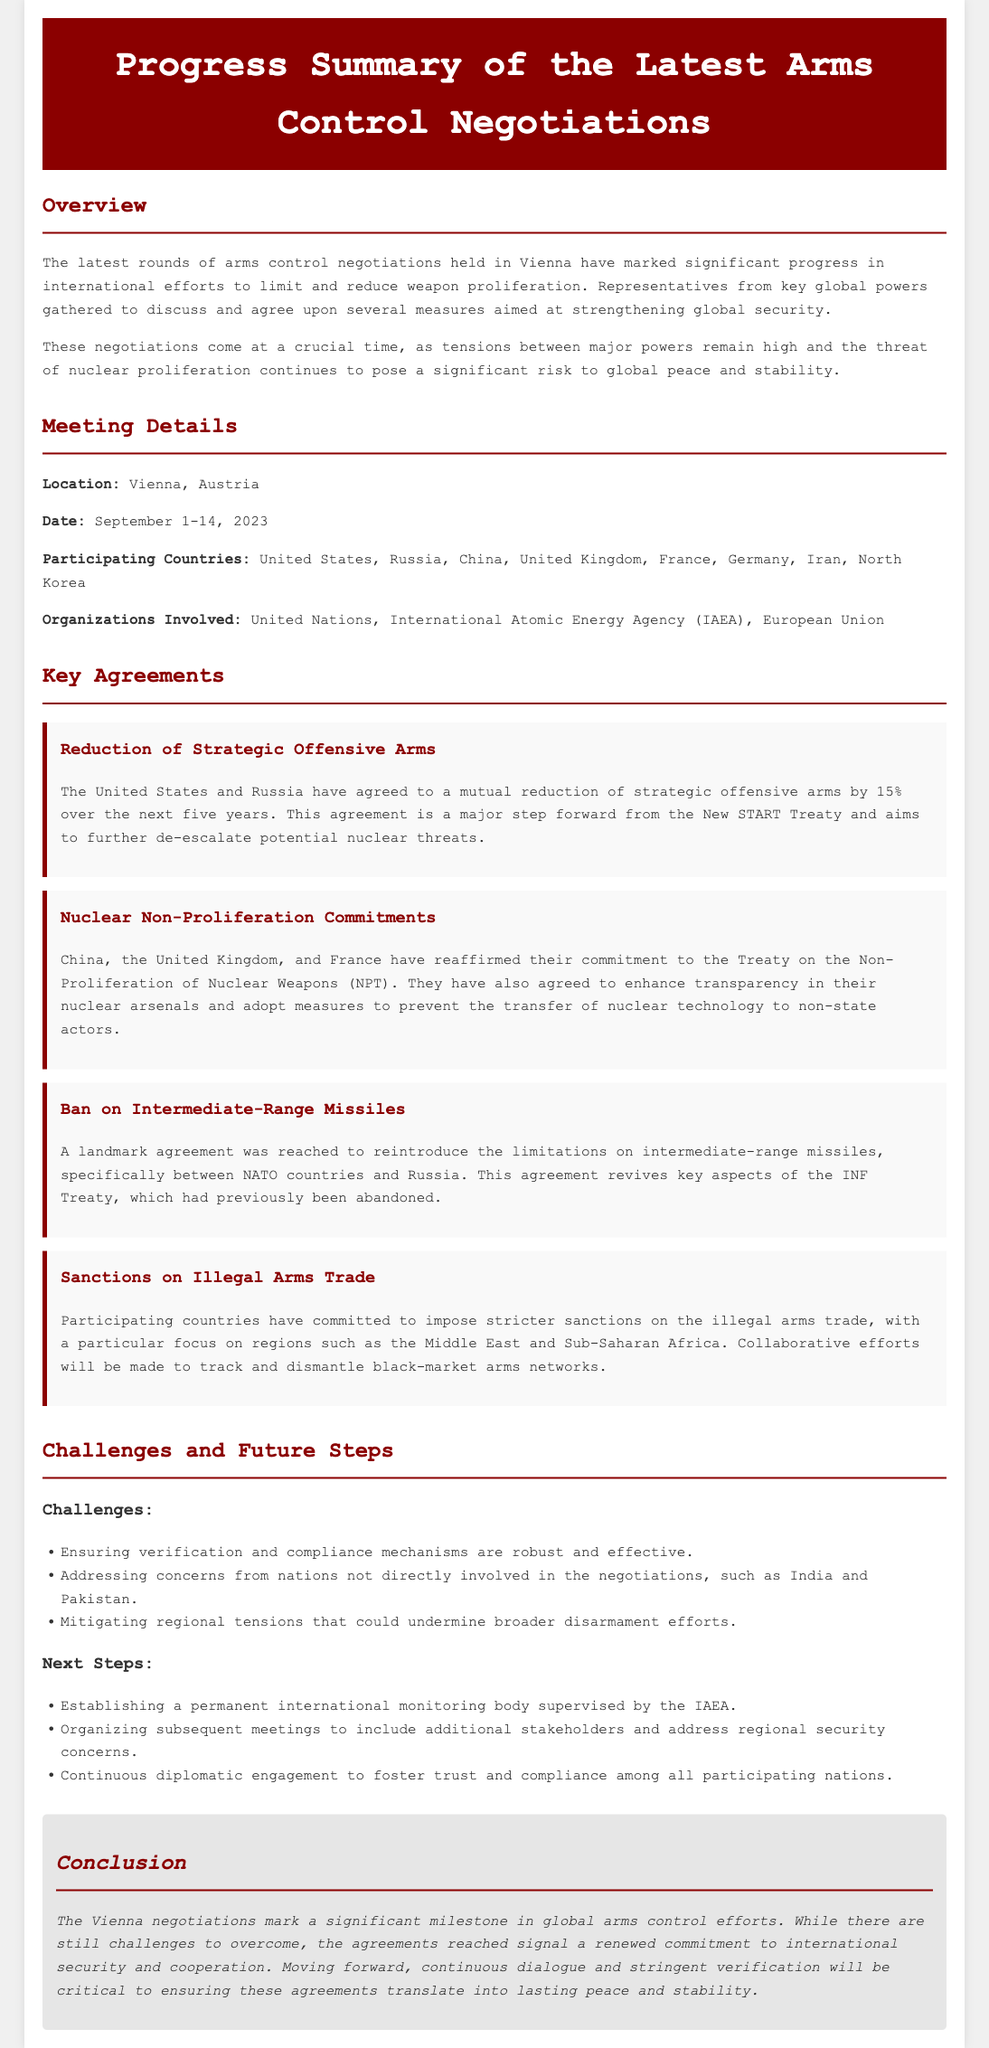What is the location of the negotiations? The location details are specified in the Meeting Details section, indicating that the negotiations were held in Vienna, Austria.
Answer: Vienna, Austria What countries participated in the negotiations? The document lists the participating countries in the Meeting Details section, including the United States, Russia, China, United Kingdom, France, Germany, Iran, and North Korea.
Answer: United States, Russia, China, United Kingdom, France, Germany, Iran, North Korea What is the percentage reduction of strategic offensive arms agreed upon by the US and Russia? The specific percentage is highlighted in the Key Agreements section under Reduction of Strategic Offensive Arms, noting a 15% reduction.
Answer: 15% Which countries reaffirmed their commitment to the NPT? The countries reaffirming their commitment to the Treaty on the Non-Proliferation of Nuclear Weapons are mentioned in the Nuclear Non-Proliferation Commitments section.
Answer: China, United Kingdom, France What significant agreement was reached regarding intermediate-range missiles? The agreement related to intermediate-range missiles is elaborated in the Key Agreements section, stating the reintroduction of limitations between NATO countries and Russia.
Answer: Reintroduce limitations What are the challenges mentioned in the negotiations? The document identifies challenges in the Challenges and Future Steps section, explicitly listing several issues involved in the negotiation process.
Answer: Verification, regional tensions What is the conclusion about the negotiations? The conclusion summarizes the outcome and significance of the negotiations in the Conclusion section, reflecting on the importance of the agreements reached.
Answer: Significant milestone What is one of the next steps proposed following the negotiations? The proposed next steps are outlined under the Next Steps heading, indicating specific actions to be taken after the negotiations.
Answer: Establishing a permanent international monitoring body What organizations were involved in the negotiations? The involved organizations are detailed in the Meeting Details section, specifying the United Nations, International Atomic Energy Agency, and European Union.
Answer: United Nations, IAEA, European Union 